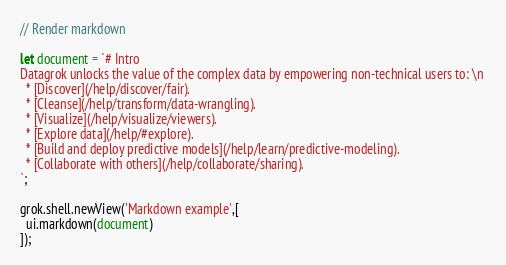<code> <loc_0><loc_0><loc_500><loc_500><_JavaScript_>// Render markdown 

let document = `# Intro
Datagrok unlocks the value of the complex data by empowering non-technical users to: \n 
  * [Discover](/help/discover/fair). 
  * [Cleanse](/help/transform/data-wrangling). 
  * [Visualize](/help/visualize/viewers).
  * [Explore data](/help/#explore).
  * [Build and deploy predictive models](/help/learn/predictive-modeling).
  *	[Collaborate with others](/help/collaborate/sharing).
`;

grok.shell.newView('Markdown example',[
  ui.markdown(document)
]);</code> 